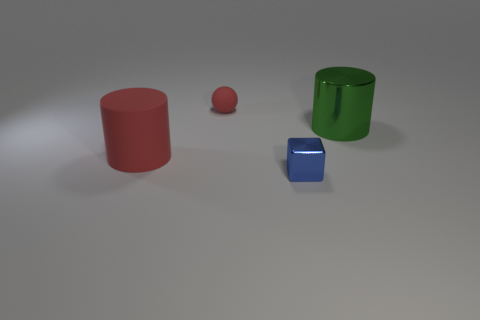Add 3 big purple rubber spheres. How many objects exist? 7 Subtract 0 cyan cubes. How many objects are left? 4 Subtract all spheres. How many objects are left? 3 Subtract 1 blocks. How many blocks are left? 0 Subtract all purple cylinders. Subtract all red balls. How many cylinders are left? 2 Subtract all yellow balls. How many red cylinders are left? 1 Subtract all red matte cylinders. Subtract all big green shiny things. How many objects are left? 2 Add 2 matte cylinders. How many matte cylinders are left? 3 Add 4 small brown shiny cylinders. How many small brown shiny cylinders exist? 4 Subtract all red cylinders. How many cylinders are left? 1 